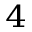Convert formula to latex. <formula><loc_0><loc_0><loc_500><loc_500>_ { 4 }</formula> 